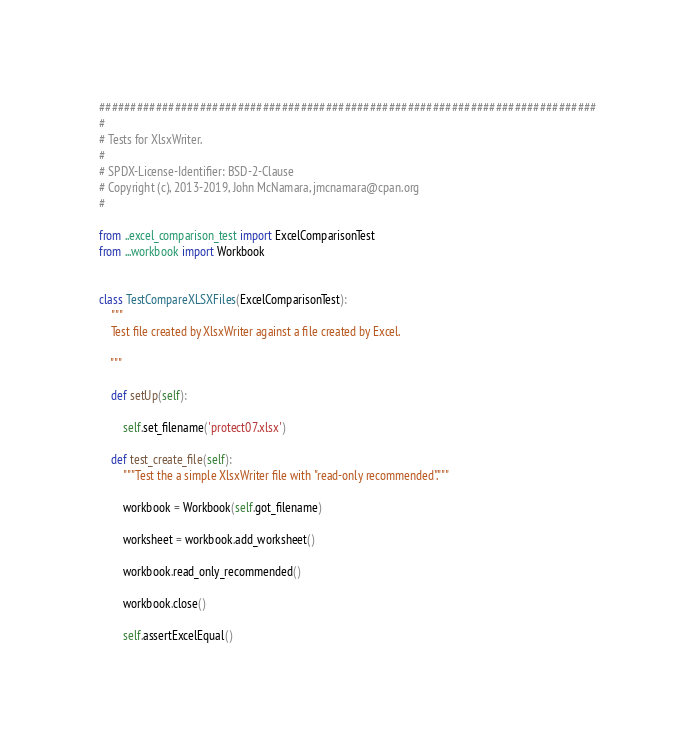Convert code to text. <code><loc_0><loc_0><loc_500><loc_500><_Python_>###############################################################################
#
# Tests for XlsxWriter.
#
# SPDX-License-Identifier: BSD-2-Clause
# Copyright (c), 2013-2019, John McNamara, jmcnamara@cpan.org
#

from ..excel_comparison_test import ExcelComparisonTest
from ...workbook import Workbook


class TestCompareXLSXFiles(ExcelComparisonTest):
    """
    Test file created by XlsxWriter against a file created by Excel.

    """

    def setUp(self):

        self.set_filename('protect07.xlsx')

    def test_create_file(self):
        """Test the a simple XlsxWriter file with "read-only recommended"."""

        workbook = Workbook(self.got_filename)

        worksheet = workbook.add_worksheet()

        workbook.read_only_recommended()

        workbook.close()

        self.assertExcelEqual()
</code> 